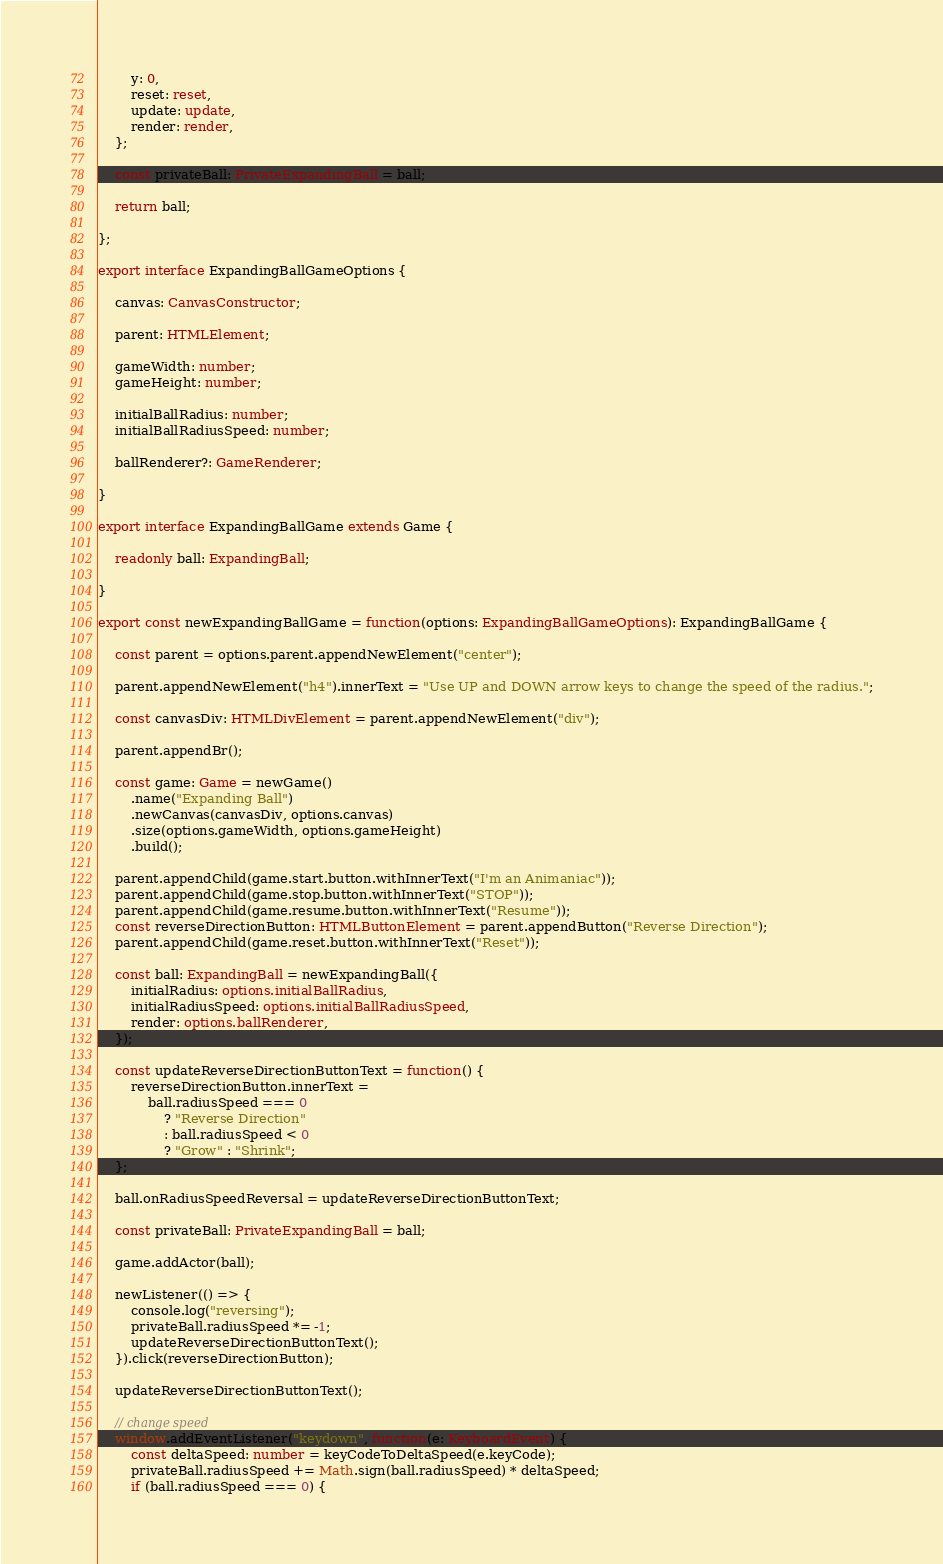<code> <loc_0><loc_0><loc_500><loc_500><_TypeScript_>        y: 0,
        reset: reset,
        update: update,
        render: render,
    };
    
    const privateBall: PrivateExpandingBall = ball;
    
    return ball;
    
};

export interface ExpandingBallGameOptions {
    
    canvas: CanvasConstructor;
    
    parent: HTMLElement;
    
    gameWidth: number;
    gameHeight: number;
    
    initialBallRadius: number;
    initialBallRadiusSpeed: number;
    
    ballRenderer?: GameRenderer;
    
}

export interface ExpandingBallGame extends Game {
    
    readonly ball: ExpandingBall;
    
}

export const newExpandingBallGame = function(options: ExpandingBallGameOptions): ExpandingBallGame {
    
    const parent = options.parent.appendNewElement("center");
    
    parent.appendNewElement("h4").innerText = "Use UP and DOWN arrow keys to change the speed of the radius.";
    
    const canvasDiv: HTMLDivElement = parent.appendNewElement("div");
    
    parent.appendBr();
    
    const game: Game = newGame()
        .name("Expanding Ball")
        .newCanvas(canvasDiv, options.canvas)
        .size(options.gameWidth, options.gameHeight)
        .build();
    
    parent.appendChild(game.start.button.withInnerText("I'm an Animaniac"));
    parent.appendChild(game.stop.button.withInnerText("STOP"));
    parent.appendChild(game.resume.button.withInnerText("Resume"));
    const reverseDirectionButton: HTMLButtonElement = parent.appendButton("Reverse Direction");
    parent.appendChild(game.reset.button.withInnerText("Reset"));
    
    const ball: ExpandingBall = newExpandingBall({
        initialRadius: options.initialBallRadius,
        initialRadiusSpeed: options.initialBallRadiusSpeed,
        render: options.ballRenderer,
    });
    
    const updateReverseDirectionButtonText = function() {
        reverseDirectionButton.innerText =
            ball.radiusSpeed === 0
                ? "Reverse Direction"
                : ball.radiusSpeed < 0
                ? "Grow" : "Shrink";
    };
    
    ball.onRadiusSpeedReversal = updateReverseDirectionButtonText;
    
    const privateBall: PrivateExpandingBall = ball;
    
    game.addActor(ball);
    
    newListener(() => {
        console.log("reversing");
        privateBall.radiusSpeed *= -1;
        updateReverseDirectionButtonText();
    }).click(reverseDirectionButton);
    
    updateReverseDirectionButtonText();
    
    // change speed
    window.addEventListener("keydown", function(e: KeyboardEvent) {
        const deltaSpeed: number = keyCodeToDeltaSpeed(e.keyCode);
        privateBall.radiusSpeed += Math.sign(ball.radiusSpeed) * deltaSpeed;
        if (ball.radiusSpeed === 0) {</code> 